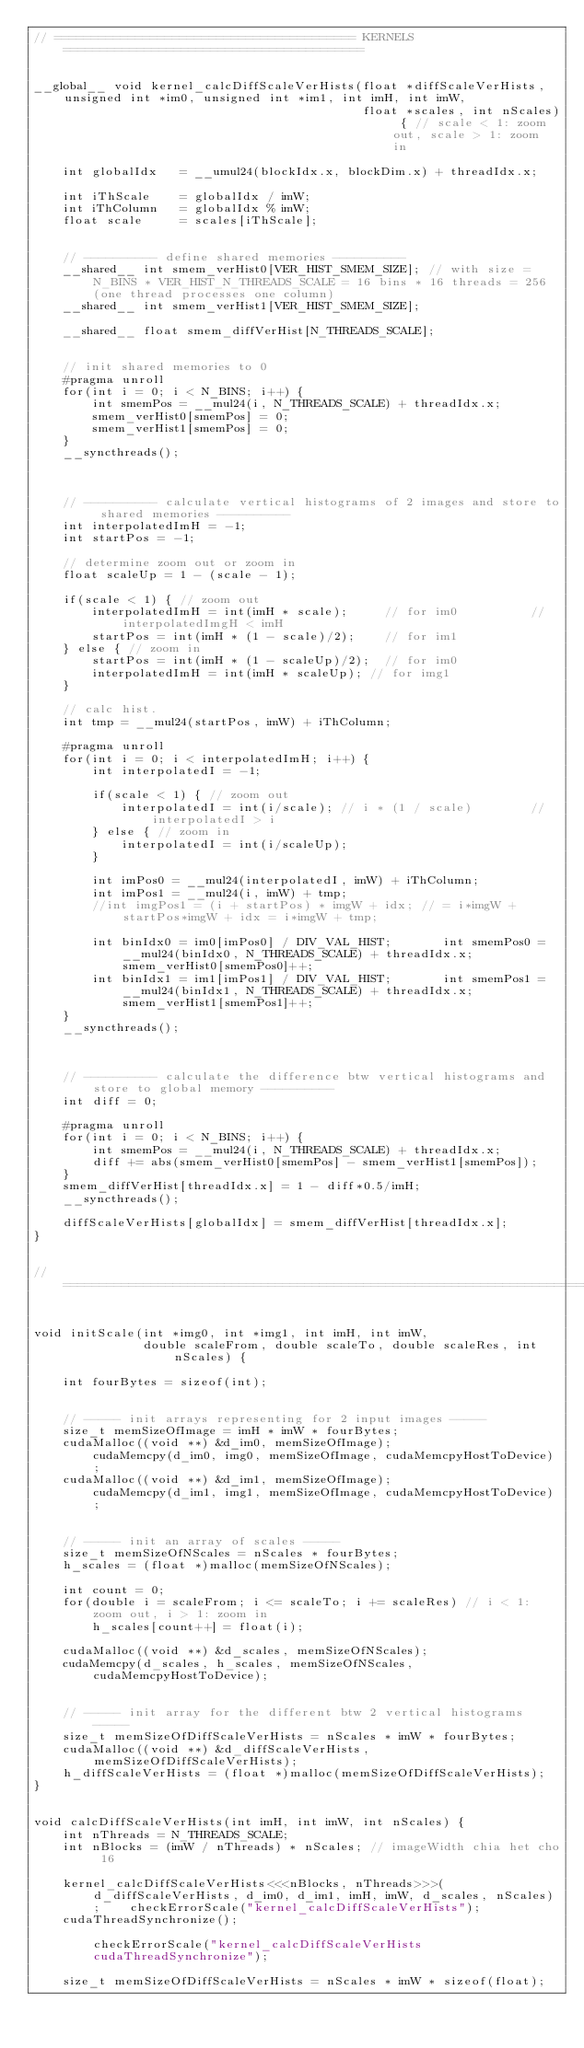<code> <loc_0><loc_0><loc_500><loc_500><_Cuda_>// ========================================= KERNELS =========================================


__global__ void kernel_calcDiffScaleVerHists(float *diffScaleVerHists, unsigned int *im0, unsigned int *im1, int imH, int imW, 
											 float *scales, int nScales) { // scale < 1: zoom out, scale > 1: zoom in

	int globalIdx	= __umul24(blockIdx.x, blockDim.x) + threadIdx.x;

	int iThScale	= globalIdx / imW;
	int iThColumn	= globalIdx % imW;
	float scale		= scales[iThScale];


	// ---------- define shared memories ----------
	__shared__ int smem_verHist0[VER_HIST_SMEM_SIZE]; // with size = N_BINS * VER_HIST_N_THREADS_SCALE = 16 bins * 16 threads = 256 (one thread processes one column)
	__shared__ int smem_verHist1[VER_HIST_SMEM_SIZE];

	__shared__ float smem_diffVerHist[N_THREADS_SCALE];


	// init shared memories to 0
	#pragma unroll
	for(int i = 0; i < N_BINS; i++) {
		int smemPos = __mul24(i, N_THREADS_SCALE) + threadIdx.x;
		smem_verHist0[smemPos] = 0;
		smem_verHist1[smemPos] = 0;
	}
	__syncthreads();



	// ---------- calculate vertical histograms of 2 images and store to shared memories ----------
	int interpolatedImH = -1;
	int startPos = -1;

	// determine zoom out or zoom in
	float scaleUp = 1 - (scale - 1);

	if(scale < 1) { // zoom out
		interpolatedImH = int(imH * scale);		// for im0			// interpolatedImgH < imH
		startPos = int(imH * (1 - scale)/2);	// for im1
	} else { // zoom in
		startPos = int(imH * (1 - scaleUp)/2);	// for im0
		interpolatedImH = int(imH * scaleUp); // for img1	
	}

	// calc hist.
	int tmp = __mul24(startPos, imW) + iThColumn;

	#pragma unroll
	for(int i = 0; i < interpolatedImH; i++) {
		int interpolatedI = -1;

		if(scale < 1) { // zoom out
			interpolatedI = int(i/scale); // i * (1 / scale)		// interpolatedI > i
		} else { // zoom in
			interpolatedI = int(i/scaleUp);
		}

		int imPos0 = __mul24(interpolatedI, imW) + iThColumn;		
		int imPos1 = __mul24(i, imW) + tmp;
		//int imgPos1 = (i + startPos) * imgW + idx; // = i*imgW + startPos*imgW + idx = i*imgW + tmp;

		int binIdx0 = im0[imPos0] / DIV_VAL_HIST;		int smemPos0 = __mul24(binIdx0, N_THREADS_SCALE) + threadIdx.x;		smem_verHist0[smemPos0]++;
		int binIdx1 = im1[imPos1] / DIV_VAL_HIST;		int smemPos1 = __mul24(binIdx1, N_THREADS_SCALE) + threadIdx.x;		smem_verHist1[smemPos1]++;
	}
	__syncthreads();



	// ---------- calculate the difference btw vertical histograms and store to global memory ----------
	int diff = 0;

	#pragma unroll
	for(int i = 0; i < N_BINS; i++) {
		int smemPos = __mul24(i, N_THREADS_SCALE) + threadIdx.x;
		diff += abs(smem_verHist0[smemPos] - smem_verHist1[smemPos]);
	}
	smem_diffVerHist[threadIdx.x] = 1 - diff*0.5/imH;
	__syncthreads();

	diffScaleVerHists[globalIdx] = smem_diffVerHist[threadIdx.x];
}


// ==========================================================================================================================


void initScale(int *img0, int *img1, int imH, int imW,
			   double scaleFrom, double scaleTo, double scaleRes, int nScales) {
    
	int fourBytes = sizeof(int);
	

	// ----- init arrays representing for 2 input images -----
	size_t memSizeOfImage = imH * imW * fourBytes;
	cudaMalloc((void **) &d_im0, memSizeOfImage);					cudaMemcpy(d_im0, img0, memSizeOfImage, cudaMemcpyHostToDevice);
	cudaMalloc((void **) &d_im1, memSizeOfImage);					cudaMemcpy(d_im1, img1, memSizeOfImage, cudaMemcpyHostToDevice);	


	// ----- init an array of scales -----
	size_t memSizeOfNScales = nScales * fourBytes;
	h_scales = (float *)malloc(memSizeOfNScales);

	int count = 0;
	for(double i = scaleFrom; i <= scaleTo; i += scaleRes) // i < 1: zoom out, i > 1: zoom in
		h_scales[count++] = float(i);

	cudaMalloc((void **) &d_scales, memSizeOfNScales);
	cudaMemcpy(d_scales, h_scales, memSizeOfNScales, cudaMemcpyHostToDevice);


	// ----- init array for the different btw 2 vertical histograms -----
	size_t memSizeOfDiffScaleVerHists = nScales * imW * fourBytes;
	cudaMalloc((void **) &d_diffScaleVerHists, memSizeOfDiffScaleVerHists);
	h_diffScaleVerHists = (float *)malloc(memSizeOfDiffScaleVerHists);
}


void calcDiffScaleVerHists(int imH, int imW, int nScales) {
	int nThreads = N_THREADS_SCALE;
	int nBlocks = (imW / nThreads) * nScales; // imageWidth chia het cho 16

	kernel_calcDiffScaleVerHists<<<nBlocks, nThreads>>>(d_diffScaleVerHists, d_im0, d_im1, imH, imW, d_scales, nScales);	checkErrorScale("kernel_calcDiffScaleVerHists");
	cudaThreadSynchronize();																								checkErrorScale("kernel_calcDiffScaleVerHists cudaThreadSynchronize");

	size_t memSizeOfDiffScaleVerHists = nScales * imW * sizeof(float);</code> 